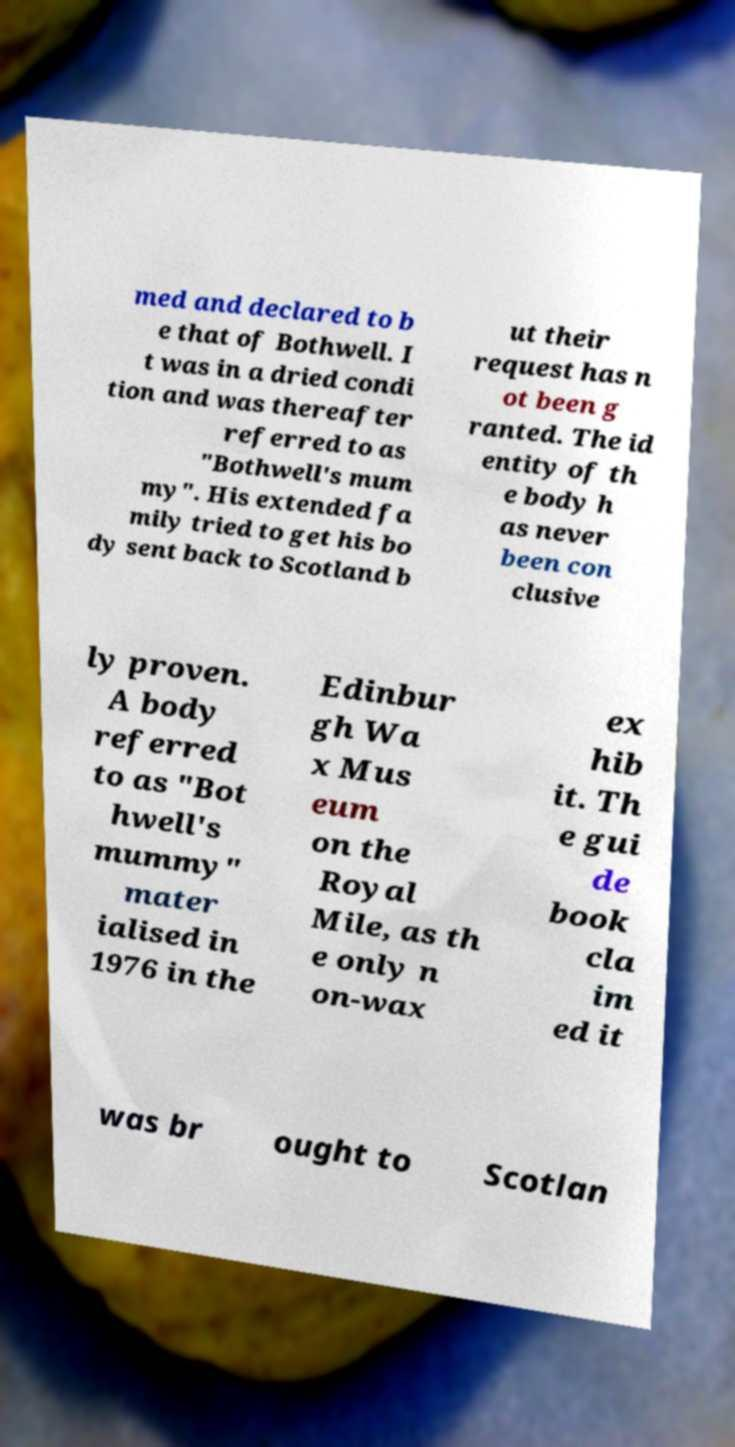I need the written content from this picture converted into text. Can you do that? med and declared to b e that of Bothwell. I t was in a dried condi tion and was thereafter referred to as "Bothwell's mum my". His extended fa mily tried to get his bo dy sent back to Scotland b ut their request has n ot been g ranted. The id entity of th e body h as never been con clusive ly proven. A body referred to as "Bot hwell's mummy" mater ialised in 1976 in the Edinbur gh Wa x Mus eum on the Royal Mile, as th e only n on-wax ex hib it. Th e gui de book cla im ed it was br ought to Scotlan 